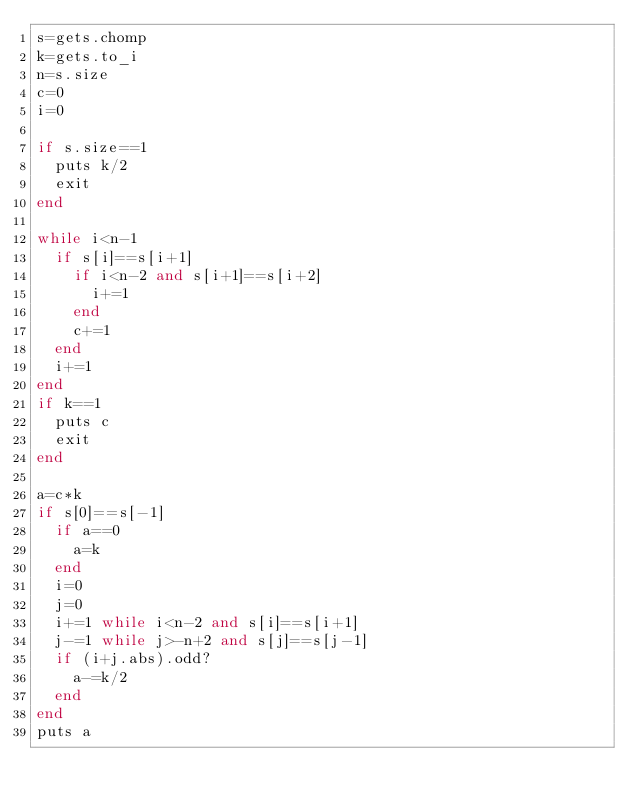<code> <loc_0><loc_0><loc_500><loc_500><_Ruby_>s=gets.chomp
k=gets.to_i
n=s.size
c=0
i=0

if s.size==1
  puts k/2
  exit
end

while i<n-1
  if s[i]==s[i+1]
    if i<n-2 and s[i+1]==s[i+2]
      i+=1
    end
    c+=1
  end
  i+=1
end
if k==1
  puts c
  exit
end

a=c*k
if s[0]==s[-1]
  if a==0
    a=k
  end
  i=0
  j=0
  i+=1 while i<n-2 and s[i]==s[i+1]
  j-=1 while j>-n+2 and s[j]==s[j-1] 
  if (i+j.abs).odd?
    a-=k/2
  end
end
puts a</code> 